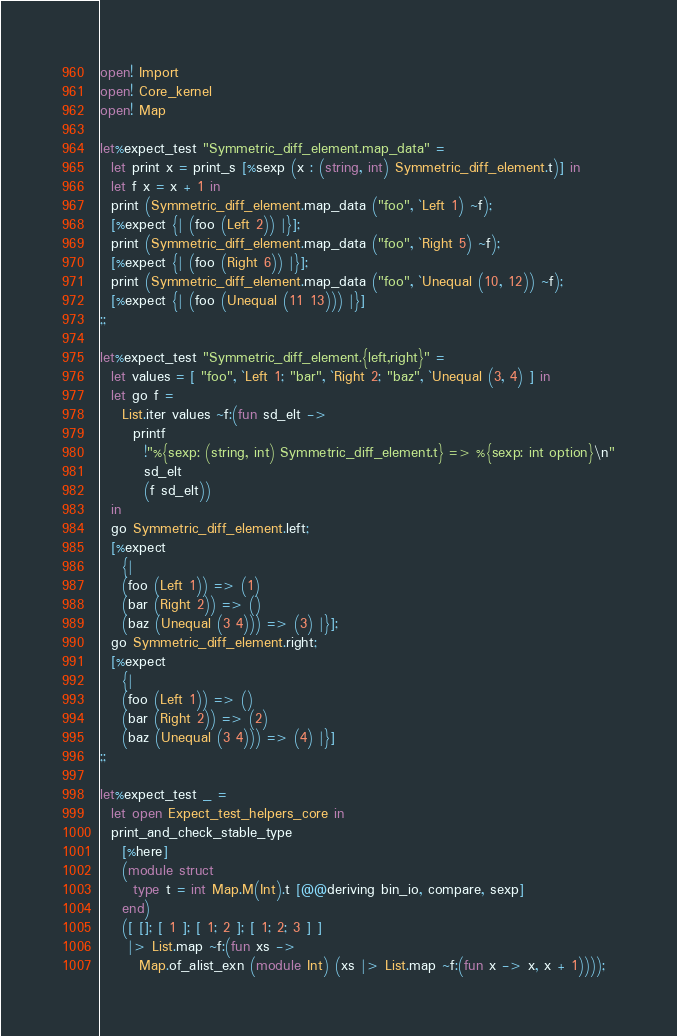Convert code to text. <code><loc_0><loc_0><loc_500><loc_500><_OCaml_>open! Import
open! Core_kernel
open! Map

let%expect_test "Symmetric_diff_element.map_data" =
  let print x = print_s [%sexp (x : (string, int) Symmetric_diff_element.t)] in
  let f x = x + 1 in
  print (Symmetric_diff_element.map_data ("foo", `Left 1) ~f);
  [%expect {| (foo (Left 2)) |}];
  print (Symmetric_diff_element.map_data ("foo", `Right 5) ~f);
  [%expect {| (foo (Right 6)) |}];
  print (Symmetric_diff_element.map_data ("foo", `Unequal (10, 12)) ~f);
  [%expect {| (foo (Unequal (11 13))) |}]
;;

let%expect_test "Symmetric_diff_element.{left,right}" =
  let values = [ "foo", `Left 1; "bar", `Right 2; "baz", `Unequal (3, 4) ] in
  let go f =
    List.iter values ~f:(fun sd_elt ->
      printf
        !"%{sexp: (string, int) Symmetric_diff_element.t} => %{sexp: int option}\n"
        sd_elt
        (f sd_elt))
  in
  go Symmetric_diff_element.left;
  [%expect
    {|
    (foo (Left 1)) => (1)
    (bar (Right 2)) => ()
    (baz (Unequal (3 4))) => (3) |}];
  go Symmetric_diff_element.right;
  [%expect
    {|
    (foo (Left 1)) => ()
    (bar (Right 2)) => (2)
    (baz (Unequal (3 4))) => (4) |}]
;;

let%expect_test _ =
  let open Expect_test_helpers_core in
  print_and_check_stable_type
    [%here]
    (module struct
      type t = int Map.M(Int).t [@@deriving bin_io, compare, sexp]
    end)
    ([ []; [ 1 ]; [ 1; 2 ]; [ 1; 2; 3 ] ]
     |> List.map ~f:(fun xs ->
       Map.of_alist_exn (module Int) (xs |> List.map ~f:(fun x -> x, x + 1))));</code> 